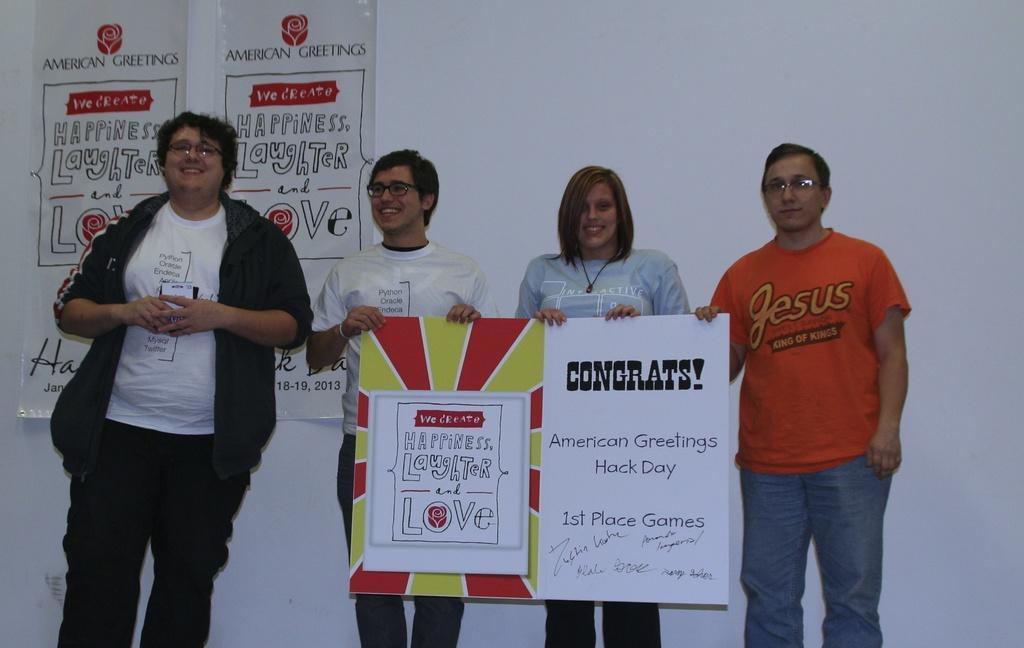How would you summarize this image in a sentence or two? In this I can see in the middle 2 persons are standing and smiling and also holding the boards in their hands. On the left side a person is smiling, this person wore a white color t-shirt, behind this person there are white color banners. On the right side there is a man, he wore orange color t-shirt. 